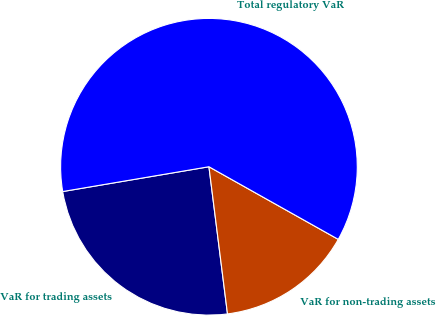Convert chart. <chart><loc_0><loc_0><loc_500><loc_500><pie_chart><fcel>VaR for trading assets<fcel>VaR for non-trading assets<fcel>Total regulatory VaR<nl><fcel>24.32%<fcel>14.86%<fcel>60.81%<nl></chart> 